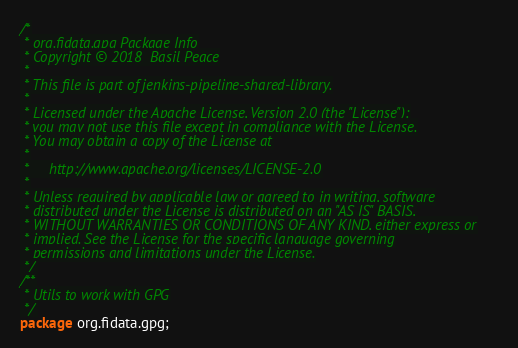Convert code to text. <code><loc_0><loc_0><loc_500><loc_500><_Java_>/*
 * org.fidata.gpg Package Info
 * Copyright © 2018  Basil Peace
 *
 * This file is part of jenkins-pipeline-shared-library.
 *
 * Licensed under the Apache License, Version 2.0 (the "License");
 * you may not use this file except in compliance with the License.
 * You may obtain a copy of the License at
 *
 *     http://www.apache.org/licenses/LICENSE-2.0
 *
 * Unless required by applicable law or agreed to in writing, software
 * distributed under the License is distributed on an "AS IS" BASIS,
 * WITHOUT WARRANTIES OR CONDITIONS OF ANY KIND, either express or
 * implied. See the License for the specific language governing
 * permissions and limitations under the License.
 */
/**
 * Utils to work with GPG
 */
package org.fidata.gpg;
</code> 